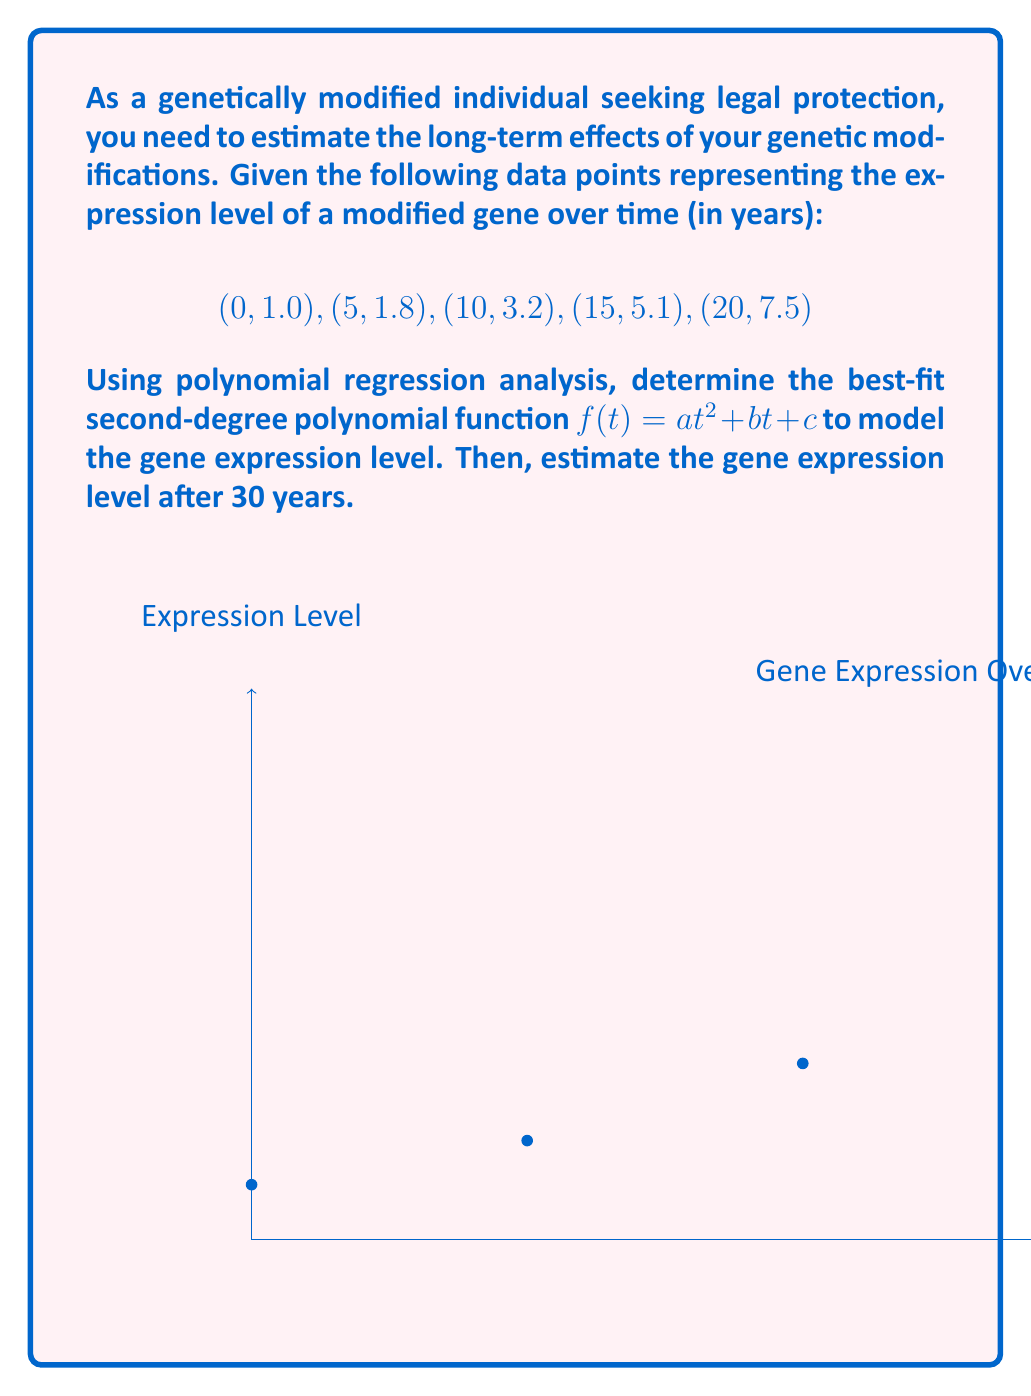What is the answer to this math problem? To find the best-fit second-degree polynomial, we'll use the least squares method:

1) Set up the system of normal equations:
   $$\begin{cases}
   \sum y = an\sum t^0 + b\sum t + c\sum t^2 \\
   \sum ty = a\sum t + b\sum t^2 + c\sum t^3 \\
   \sum t^2y = a\sum t^2 + b\sum t^3 + c\sum t^4
   \end{cases}$$

2) Calculate the sums:
   $\sum t^0 = 5$, $\sum t = 50$, $\sum t^2 = 750$, $\sum t^3 = 13750$, $\sum t^4 = 287500$
   $\sum y = 18.6$, $\sum ty = 249$, $\sum t^2y = 4025$

3) Substitute into the normal equations:
   $$\begin{cases}
   18.6 = 5a + 50b + 750c \\
   249 = 50a + 750b + 13750c \\
   4025 = 750a + 13750b + 287500c
   \end{cases}$$

4) Solve the system of equations (using a calculator or computer algebra system):
   $a \approx 0.0112$, $b \approx 0.0788$, $c \approx 1.0400$

5) The best-fit polynomial is:
   $$f(t) \approx 0.0112t^2 + 0.0788t + 1.0400$$

6) To estimate the gene expression level after 30 years, evaluate $f(30)$:
   $$f(30) \approx 0.0112(30)^2 + 0.0788(30) + 1.0400 \approx 13.6400$$
Answer: $f(30) \approx 13.64$ 